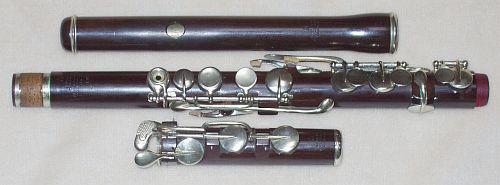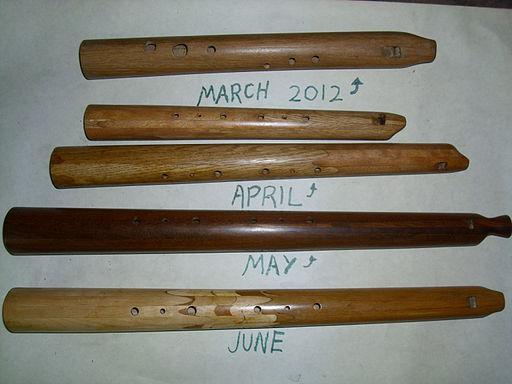The first image is the image on the left, the second image is the image on the right. Given the left and right images, does the statement "In one of the images, the second flute from the bottom is a darker color than the third flute from the bottom." hold true? Answer yes or no. Yes. 